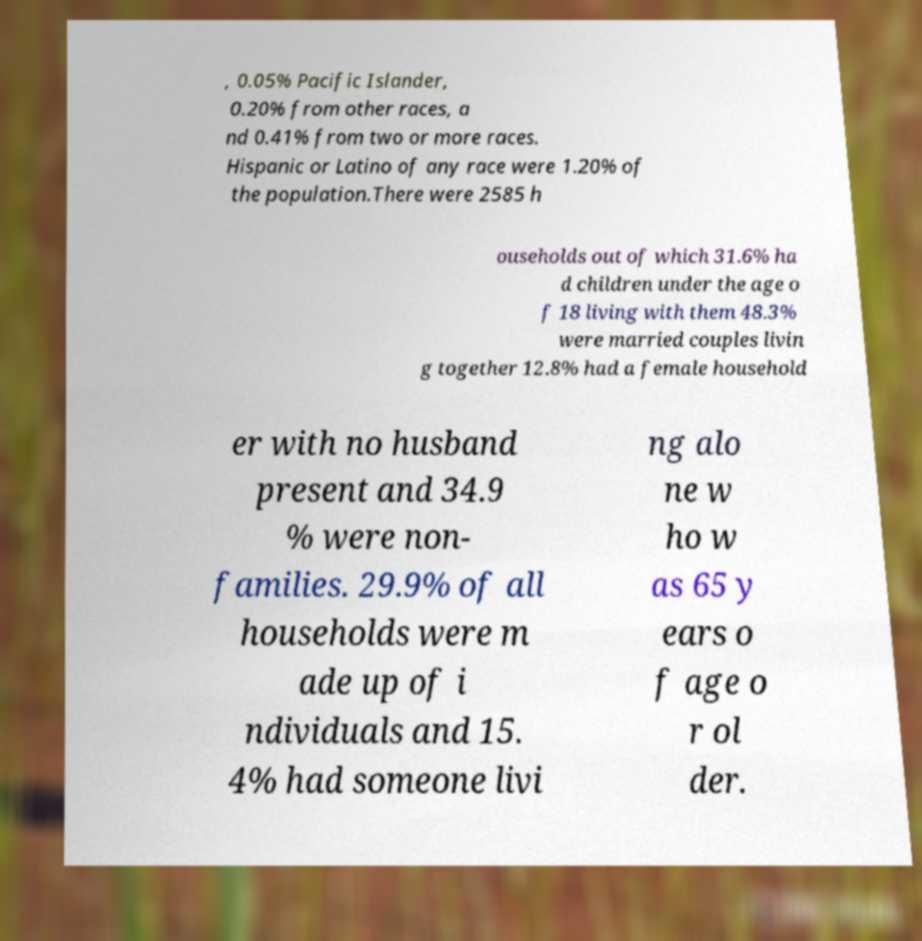For documentation purposes, I need the text within this image transcribed. Could you provide that? , 0.05% Pacific Islander, 0.20% from other races, a nd 0.41% from two or more races. Hispanic or Latino of any race were 1.20% of the population.There were 2585 h ouseholds out of which 31.6% ha d children under the age o f 18 living with them 48.3% were married couples livin g together 12.8% had a female household er with no husband present and 34.9 % were non- families. 29.9% of all households were m ade up of i ndividuals and 15. 4% had someone livi ng alo ne w ho w as 65 y ears o f age o r ol der. 